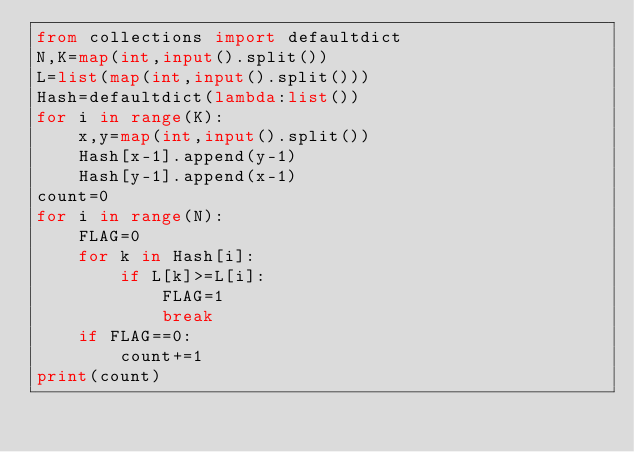<code> <loc_0><loc_0><loc_500><loc_500><_Python_>from collections import defaultdict
N,K=map(int,input().split())
L=list(map(int,input().split()))
Hash=defaultdict(lambda:list())
for i in range(K):
    x,y=map(int,input().split())
    Hash[x-1].append(y-1)
    Hash[y-1].append(x-1)
count=0
for i in range(N):
    FLAG=0
    for k in Hash[i]:
        if L[k]>=L[i]:
            FLAG=1
            break
    if FLAG==0:
        count+=1
print(count)</code> 